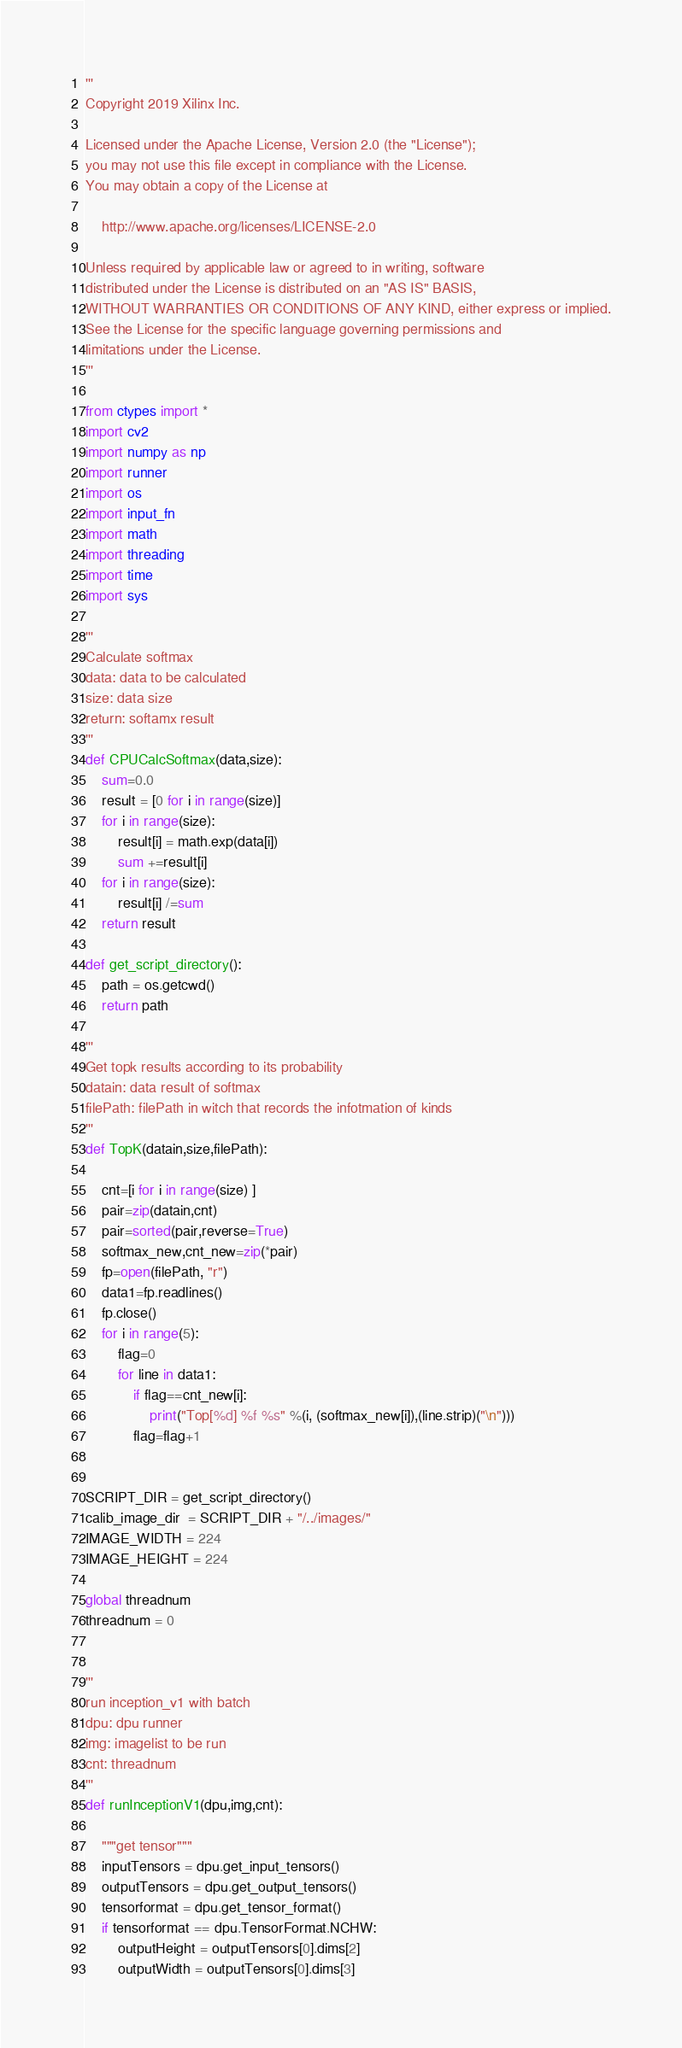<code> <loc_0><loc_0><loc_500><loc_500><_Python_>'''
Copyright 2019 Xilinx Inc.

Licensed under the Apache License, Version 2.0 (the "License");
you may not use this file except in compliance with the License.
You may obtain a copy of the License at

    http://www.apache.org/licenses/LICENSE-2.0

Unless required by applicable law or agreed to in writing, software
distributed under the License is distributed on an "AS IS" BASIS,
WITHOUT WARRANTIES OR CONDITIONS OF ANY KIND, either express or implied.
See the License for the specific language governing permissions and
limitations under the License.
'''

from ctypes import *
import cv2
import numpy as np
import runner
import os
import input_fn
import math
import threading
import time
import sys

'''
Calculate softmax
data: data to be calculated
size: data size
return: softamx result
'''
def CPUCalcSoftmax(data,size):
    sum=0.0
    result = [0 for i in range(size)]
    for i in range(size):
        result[i] = math.exp(data[i])
        sum +=result[i]
    for i in range(size):
        result[i] /=sum
    return result

def get_script_directory():
    path = os.getcwd()
    return path

'''
Get topk results according to its probability
datain: data result of softmax
filePath: filePath in witch that records the infotmation of kinds
'''
def TopK(datain,size,filePath):

    cnt=[i for i in range(size) ]
    pair=zip(datain,cnt)
    pair=sorted(pair,reverse=True)
    softmax_new,cnt_new=zip(*pair)
    fp=open(filePath, "r")
    data1=fp.readlines()
    fp.close()
    for i in range(5):
        flag=0
        for line in data1:
            if flag==cnt_new[i]:
                print("Top[%d] %f %s" %(i, (softmax_new[i]),(line.strip)("\n")))
            flag=flag+1


SCRIPT_DIR = get_script_directory()
calib_image_dir  = SCRIPT_DIR + "/../images/"
IMAGE_WIDTH = 224
IMAGE_HEIGHT = 224

global threadnum
threadnum = 0


'''
run inception_v1 with batch
dpu: dpu runner
img: imagelist to be run
cnt: threadnum
'''
def runInceptionV1(dpu,img,cnt):

    """get tensor"""
    inputTensors = dpu.get_input_tensors()
    outputTensors = dpu.get_output_tensors()
    tensorformat = dpu.get_tensor_format()
    if tensorformat == dpu.TensorFormat.NCHW:
        outputHeight = outputTensors[0].dims[2]
        outputWidth = outputTensors[0].dims[3]</code> 